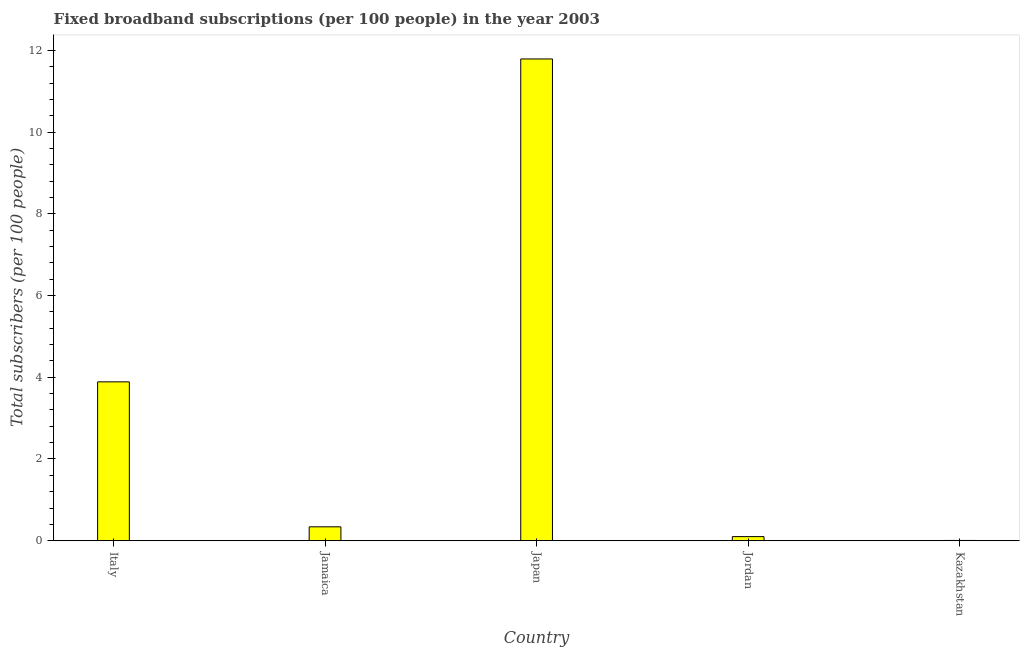What is the title of the graph?
Make the answer very short. Fixed broadband subscriptions (per 100 people) in the year 2003. What is the label or title of the Y-axis?
Keep it short and to the point. Total subscribers (per 100 people). What is the total number of fixed broadband subscriptions in Jamaica?
Make the answer very short. 0.34. Across all countries, what is the maximum total number of fixed broadband subscriptions?
Keep it short and to the point. 11.79. Across all countries, what is the minimum total number of fixed broadband subscriptions?
Your answer should be compact. 0.01. In which country was the total number of fixed broadband subscriptions maximum?
Make the answer very short. Japan. In which country was the total number of fixed broadband subscriptions minimum?
Provide a succinct answer. Kazakhstan. What is the sum of the total number of fixed broadband subscriptions?
Ensure brevity in your answer.  16.13. What is the difference between the total number of fixed broadband subscriptions in Jamaica and Kazakhstan?
Make the answer very short. 0.33. What is the average total number of fixed broadband subscriptions per country?
Offer a terse response. 3.23. What is the median total number of fixed broadband subscriptions?
Make the answer very short. 0.34. In how many countries, is the total number of fixed broadband subscriptions greater than 10.8 ?
Your answer should be compact. 1. What is the ratio of the total number of fixed broadband subscriptions in Jamaica to that in Japan?
Your answer should be compact. 0.03. Is the difference between the total number of fixed broadband subscriptions in Jordan and Kazakhstan greater than the difference between any two countries?
Your answer should be very brief. No. What is the difference between the highest and the second highest total number of fixed broadband subscriptions?
Give a very brief answer. 7.9. Is the sum of the total number of fixed broadband subscriptions in Jamaica and Japan greater than the maximum total number of fixed broadband subscriptions across all countries?
Ensure brevity in your answer.  Yes. What is the difference between the highest and the lowest total number of fixed broadband subscriptions?
Your response must be concise. 11.78. In how many countries, is the total number of fixed broadband subscriptions greater than the average total number of fixed broadband subscriptions taken over all countries?
Keep it short and to the point. 2. How many bars are there?
Provide a short and direct response. 5. Are all the bars in the graph horizontal?
Offer a terse response. No. What is the Total subscribers (per 100 people) in Italy?
Provide a succinct answer. 3.89. What is the Total subscribers (per 100 people) of Jamaica?
Ensure brevity in your answer.  0.34. What is the Total subscribers (per 100 people) in Japan?
Offer a terse response. 11.79. What is the Total subscribers (per 100 people) of Jordan?
Ensure brevity in your answer.  0.1. What is the Total subscribers (per 100 people) of Kazakhstan?
Your response must be concise. 0.01. What is the difference between the Total subscribers (per 100 people) in Italy and Jamaica?
Ensure brevity in your answer.  3.55. What is the difference between the Total subscribers (per 100 people) in Italy and Japan?
Your response must be concise. -7.9. What is the difference between the Total subscribers (per 100 people) in Italy and Jordan?
Offer a very short reply. 3.79. What is the difference between the Total subscribers (per 100 people) in Italy and Kazakhstan?
Give a very brief answer. 3.88. What is the difference between the Total subscribers (per 100 people) in Jamaica and Japan?
Keep it short and to the point. -11.45. What is the difference between the Total subscribers (per 100 people) in Jamaica and Jordan?
Offer a terse response. 0.24. What is the difference between the Total subscribers (per 100 people) in Jamaica and Kazakhstan?
Provide a short and direct response. 0.33. What is the difference between the Total subscribers (per 100 people) in Japan and Jordan?
Ensure brevity in your answer.  11.69. What is the difference between the Total subscribers (per 100 people) in Japan and Kazakhstan?
Ensure brevity in your answer.  11.78. What is the difference between the Total subscribers (per 100 people) in Jordan and Kazakhstan?
Provide a succinct answer. 0.09. What is the ratio of the Total subscribers (per 100 people) in Italy to that in Jamaica?
Your response must be concise. 11.44. What is the ratio of the Total subscribers (per 100 people) in Italy to that in Japan?
Offer a very short reply. 0.33. What is the ratio of the Total subscribers (per 100 people) in Italy to that in Jordan?
Ensure brevity in your answer.  38.78. What is the ratio of the Total subscribers (per 100 people) in Italy to that in Kazakhstan?
Offer a very short reply. 574.57. What is the ratio of the Total subscribers (per 100 people) in Jamaica to that in Japan?
Make the answer very short. 0.03. What is the ratio of the Total subscribers (per 100 people) in Jamaica to that in Jordan?
Provide a succinct answer. 3.39. What is the ratio of the Total subscribers (per 100 people) in Jamaica to that in Kazakhstan?
Provide a succinct answer. 50.24. What is the ratio of the Total subscribers (per 100 people) in Japan to that in Jordan?
Your answer should be very brief. 117.61. What is the ratio of the Total subscribers (per 100 people) in Japan to that in Kazakhstan?
Offer a very short reply. 1742.25. What is the ratio of the Total subscribers (per 100 people) in Jordan to that in Kazakhstan?
Give a very brief answer. 14.81. 